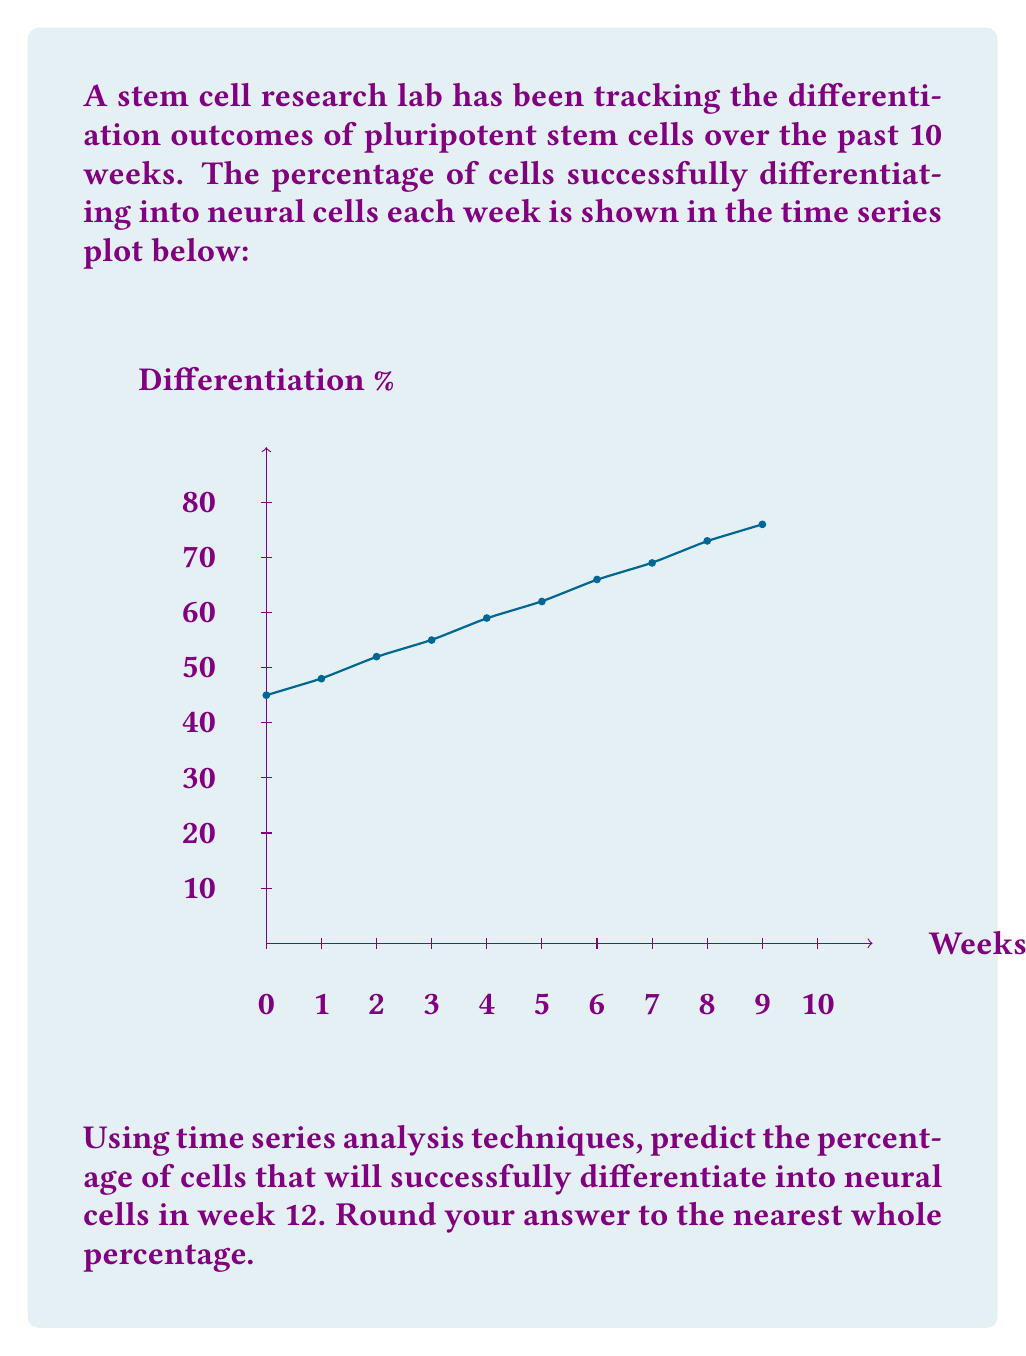Solve this math problem. To predict the differentiation percentage for week 12, we'll use a linear regression model based on the given time series data. Here's the step-by-step process:

1. Identify the data points:
   Week (x): 1, 2, 3, 4, 5, 6, 7, 8, 9, 10
   Percentage (y): 45, 48, 52, 55, 59, 62, 66, 69, 73, 76

2. Calculate the means:
   $\bar{x} = \frac{1+2+3+4+5+6+7+8+9+10}{10} = 5.5$
   $\bar{y} = \frac{45+48+52+55+59+62+66+69+73+76}{10} = 60.5$

3. Calculate the slope (m) using the formula:
   $m = \frac{\sum(x_i - \bar{x})(y_i - \bar{y})}{\sum(x_i - \bar{x})^2}$

   Numerator: 346.5
   Denominator: 82.5
   $m = \frac{346.5}{82.5} = 4.2$

4. Calculate the y-intercept (b) using the formula:
   $b = \bar{y} - m\bar{x}$
   $b = 60.5 - (4.2 * 5.5) = 37.4$

5. The linear regression equation is:
   $y = mx + b = 4.2x + 37.4$

6. To predict the percentage for week 12, substitute x = 12:
   $y = 4.2(12) + 37.4 = 87.8$

7. Rounding to the nearest whole percentage:
   87.8% ≈ 88%
Answer: 88% 